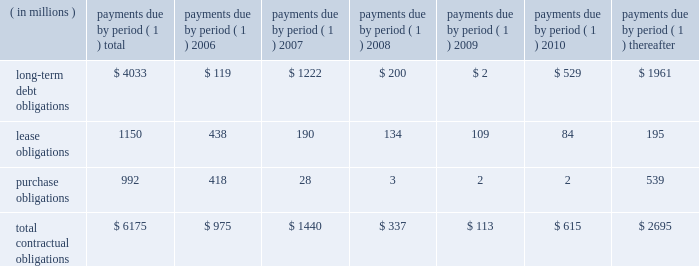57management's discussion and analysis of financial condition and results of operations facility include covenants relating to net interest coverage and total debt-to-book capitalization ratios .
The company was in compliance with the terms of the 3-year credit facility at december 31 , 2005 .
The company has never borrowed under its domestic revolving credit facilities .
Utilization of the non-u.s .
Credit facilities may also be dependent on the company's ability to meet certain conditions at the time a borrowing is requested .
Contractual obligations , guarantees , and other purchase commitments contractual obligations summarized in the table below are the company's obligations and commitments to make future payments under debt obligations ( assuming earliest possible exercise of put rights by holders ) , lease payment obligations , and purchase obligations as of december 31 , 2005 .
Payments due by period ( 1 ) ( in millions ) total 2006 2007 2008 2009 2010 thereafter .
( 1 ) amounts included represent firm , non-cancelable commitments .
Debt obligations : at december 31 , 2005 , the company's long-term debt obligations , including current maturities and unamortized discount and issue costs , totaled $ 4.0 billion , as compared to $ 5.0 billion at december 31 , 2004 .
A table of all outstanding long-term debt securities can be found in note 4 , ""debt and credit facilities'' to the company's consolidated financial statements .
As previously discussed , the decrease in the long- term debt obligations as compared to december 31 , 2004 , was due to the redemptions and repurchases of $ 1.0 billion principal amount of outstanding securities during 2005 .
Also , as previously discussed , the remaining $ 118 million of 7.6% ( 7.6 % ) notes due january 1 , 2007 were reclassified to current maturities of long-term debt .
Lease obligations : the company owns most of its major facilities , but does lease certain office , factory and warehouse space , land , and information technology and other equipment under principally non-cancelable operating leases .
At december 31 , 2005 , future minimum lease obligations , net of minimum sublease rentals , totaled $ 1.2 billion .
Rental expense , net of sublease income , was $ 254 million in 2005 , $ 217 million in 2004 and $ 223 million in 2003 .
Purchase obligations : the company has entered into agreements for the purchase of inventory , license of software , promotional agreements , and research and development agreements which are firm commitments and are not cancelable .
The longest of these agreements extends through 2015 .
Total payments expected to be made under these agreements total $ 992 million .
Commitments under other long-term agreements : the company has entered into certain long-term agreements to purchase software , components , supplies and materials from suppliers .
Most of the agreements extend for periods of one to three years ( three to five years for software ) .
However , generally these agreements do not obligate the company to make any purchases , and many permit the company to terminate the agreement with advance notice ( usually ranging from 60 to 180 days ) .
If the company were to terminate these agreements , it generally would be liable for certain termination charges , typically based on work performed and supplier on-hand inventory and raw materials attributable to canceled orders .
The company's liability would only arise in the event it terminates the agreements for reasons other than ""cause.'' in 2003 , the company entered into outsourcing contracts for certain corporate functions , such as benefit administration and information technology related services .
These contracts generally extend for 10 years and are expected to expire in 2013 .
The total payments under these contracts are approximately $ 3 billion over 10 years ; however , these contracts can be terminated .
Termination would result in a penalty substantially less than the annual contract payments .
The company would also be required to find another source for these services , including the possibility of performing them in-house .
As is customary in bidding for and completing network infrastructure projects and pursuant to a practice the company has followed for many years , the company has a number of performance/bid bonds and standby letters of credit outstanding , primarily relating to projects of government and enterprise mobility solutions segment and the networks segment .
These instruments normally have maturities of up to three years and are standard in the .
What was the ratio of the rental expense , net of sublease income in 2005 compared to 2004? 
Computations: (254 / 217)
Answer: 1.17051. 57management's discussion and analysis of financial condition and results of operations facility include covenants relating to net interest coverage and total debt-to-book capitalization ratios .
The company was in compliance with the terms of the 3-year credit facility at december 31 , 2005 .
The company has never borrowed under its domestic revolving credit facilities .
Utilization of the non-u.s .
Credit facilities may also be dependent on the company's ability to meet certain conditions at the time a borrowing is requested .
Contractual obligations , guarantees , and other purchase commitments contractual obligations summarized in the table below are the company's obligations and commitments to make future payments under debt obligations ( assuming earliest possible exercise of put rights by holders ) , lease payment obligations , and purchase obligations as of december 31 , 2005 .
Payments due by period ( 1 ) ( in millions ) total 2006 2007 2008 2009 2010 thereafter .
( 1 ) amounts included represent firm , non-cancelable commitments .
Debt obligations : at december 31 , 2005 , the company's long-term debt obligations , including current maturities and unamortized discount and issue costs , totaled $ 4.0 billion , as compared to $ 5.0 billion at december 31 , 2004 .
A table of all outstanding long-term debt securities can be found in note 4 , ""debt and credit facilities'' to the company's consolidated financial statements .
As previously discussed , the decrease in the long- term debt obligations as compared to december 31 , 2004 , was due to the redemptions and repurchases of $ 1.0 billion principal amount of outstanding securities during 2005 .
Also , as previously discussed , the remaining $ 118 million of 7.6% ( 7.6 % ) notes due january 1 , 2007 were reclassified to current maturities of long-term debt .
Lease obligations : the company owns most of its major facilities , but does lease certain office , factory and warehouse space , land , and information technology and other equipment under principally non-cancelable operating leases .
At december 31 , 2005 , future minimum lease obligations , net of minimum sublease rentals , totaled $ 1.2 billion .
Rental expense , net of sublease income , was $ 254 million in 2005 , $ 217 million in 2004 and $ 223 million in 2003 .
Purchase obligations : the company has entered into agreements for the purchase of inventory , license of software , promotional agreements , and research and development agreements which are firm commitments and are not cancelable .
The longest of these agreements extends through 2015 .
Total payments expected to be made under these agreements total $ 992 million .
Commitments under other long-term agreements : the company has entered into certain long-term agreements to purchase software , components , supplies and materials from suppliers .
Most of the agreements extend for periods of one to three years ( three to five years for software ) .
However , generally these agreements do not obligate the company to make any purchases , and many permit the company to terminate the agreement with advance notice ( usually ranging from 60 to 180 days ) .
If the company were to terminate these agreements , it generally would be liable for certain termination charges , typically based on work performed and supplier on-hand inventory and raw materials attributable to canceled orders .
The company's liability would only arise in the event it terminates the agreements for reasons other than ""cause.'' in 2003 , the company entered into outsourcing contracts for certain corporate functions , such as benefit administration and information technology related services .
These contracts generally extend for 10 years and are expected to expire in 2013 .
The total payments under these contracts are approximately $ 3 billion over 10 years ; however , these contracts can be terminated .
Termination would result in a penalty substantially less than the annual contract payments .
The company would also be required to find another source for these services , including the possibility of performing them in-house .
As is customary in bidding for and completing network infrastructure projects and pursuant to a practice the company has followed for many years , the company has a number of performance/bid bonds and standby letters of credit outstanding , primarily relating to projects of government and enterprise mobility solutions segment and the networks segment .
These instruments normally have maturities of up to three years and are standard in the .
What was the percentage change in total contractual obligations from 2006 to 2010? 
Rationale: the total contractual obligations decreases by 36.9% from 2006 to 2010 . to find this out we subtract these two times from each other and then take the solution . we then multiple that solution by the 2006 number to get 36.9% .
Computations: ((975 - 615) / 975)
Answer: 0.36923. 57management's discussion and analysis of financial condition and results of operations facility include covenants relating to net interest coverage and total debt-to-book capitalization ratios .
The company was in compliance with the terms of the 3-year credit facility at december 31 , 2005 .
The company has never borrowed under its domestic revolving credit facilities .
Utilization of the non-u.s .
Credit facilities may also be dependent on the company's ability to meet certain conditions at the time a borrowing is requested .
Contractual obligations , guarantees , and other purchase commitments contractual obligations summarized in the table below are the company's obligations and commitments to make future payments under debt obligations ( assuming earliest possible exercise of put rights by holders ) , lease payment obligations , and purchase obligations as of december 31 , 2005 .
Payments due by period ( 1 ) ( in millions ) total 2006 2007 2008 2009 2010 thereafter .
( 1 ) amounts included represent firm , non-cancelable commitments .
Debt obligations : at december 31 , 2005 , the company's long-term debt obligations , including current maturities and unamortized discount and issue costs , totaled $ 4.0 billion , as compared to $ 5.0 billion at december 31 , 2004 .
A table of all outstanding long-term debt securities can be found in note 4 , ""debt and credit facilities'' to the company's consolidated financial statements .
As previously discussed , the decrease in the long- term debt obligations as compared to december 31 , 2004 , was due to the redemptions and repurchases of $ 1.0 billion principal amount of outstanding securities during 2005 .
Also , as previously discussed , the remaining $ 118 million of 7.6% ( 7.6 % ) notes due january 1 , 2007 were reclassified to current maturities of long-term debt .
Lease obligations : the company owns most of its major facilities , but does lease certain office , factory and warehouse space , land , and information technology and other equipment under principally non-cancelable operating leases .
At december 31 , 2005 , future minimum lease obligations , net of minimum sublease rentals , totaled $ 1.2 billion .
Rental expense , net of sublease income , was $ 254 million in 2005 , $ 217 million in 2004 and $ 223 million in 2003 .
Purchase obligations : the company has entered into agreements for the purchase of inventory , license of software , promotional agreements , and research and development agreements which are firm commitments and are not cancelable .
The longest of these agreements extends through 2015 .
Total payments expected to be made under these agreements total $ 992 million .
Commitments under other long-term agreements : the company has entered into certain long-term agreements to purchase software , components , supplies and materials from suppliers .
Most of the agreements extend for periods of one to three years ( three to five years for software ) .
However , generally these agreements do not obligate the company to make any purchases , and many permit the company to terminate the agreement with advance notice ( usually ranging from 60 to 180 days ) .
If the company were to terminate these agreements , it generally would be liable for certain termination charges , typically based on work performed and supplier on-hand inventory and raw materials attributable to canceled orders .
The company's liability would only arise in the event it terminates the agreements for reasons other than ""cause.'' in 2003 , the company entered into outsourcing contracts for certain corporate functions , such as benefit administration and information technology related services .
These contracts generally extend for 10 years and are expected to expire in 2013 .
The total payments under these contracts are approximately $ 3 billion over 10 years ; however , these contracts can be terminated .
Termination would result in a penalty substantially less than the annual contract payments .
The company would also be required to find another source for these services , including the possibility of performing them in-house .
As is customary in bidding for and completing network infrastructure projects and pursuant to a practice the company has followed for many years , the company has a number of performance/bid bonds and standby letters of credit outstanding , primarily relating to projects of government and enterprise mobility solutions segment and the networks segment .
These instruments normally have maturities of up to three years and are standard in the .
What percent of the total contractual obligations in 2006 were long-term debt obligations? 
Computations: (119 / 975)
Answer: 0.12205. 